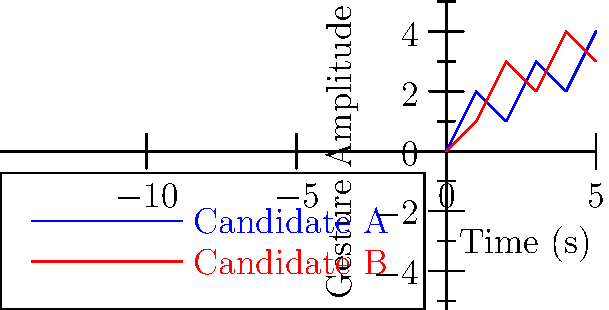Based on the motion capture data visualizations of hand gestures during a political debate, which candidate's gestures appear more consistent with persuasive public speaking techniques, and how might this impact voter perception? To answer this question, we need to analyze the gesture patterns of both candidates:

1. Candidate A (blue line):
   - Shows a more irregular pattern
   - Gesture amplitude varies between 1 and 4 units
   - Frequent changes in amplitude

2. Candidate B (red line):
   - Demonstrates a more consistent pattern
   - Gesture amplitude generally increases over time
   - Smoother transitions between amplitudes

3. Persuasive public speaking techniques typically involve:
   - Consistent and controlled gestures
   - Gradually building emphasis
   - Avoiding erratic movements

4. Impact on voter perception:
   - Consistent gestures (Candidate B) may convey confidence and control
   - Irregular gestures (Candidate A) might be perceived as nervousness or lack of preparation
   - Voters often subconsciously interpret body language cues

5. Relevance to comparative politics:
   - Non-verbal communication can significantly influence political outcomes
   - Cross-cultural differences in gesture interpretation may affect international relations
   - Biomechanical analysis of political figures can provide insights into leadership styles and effectiveness

Given these factors, Candidate B's gestures appear more consistent with persuasive public speaking techniques, which may positively impact voter perception.
Answer: Candidate B, potentially leading to more positive voter perception. 